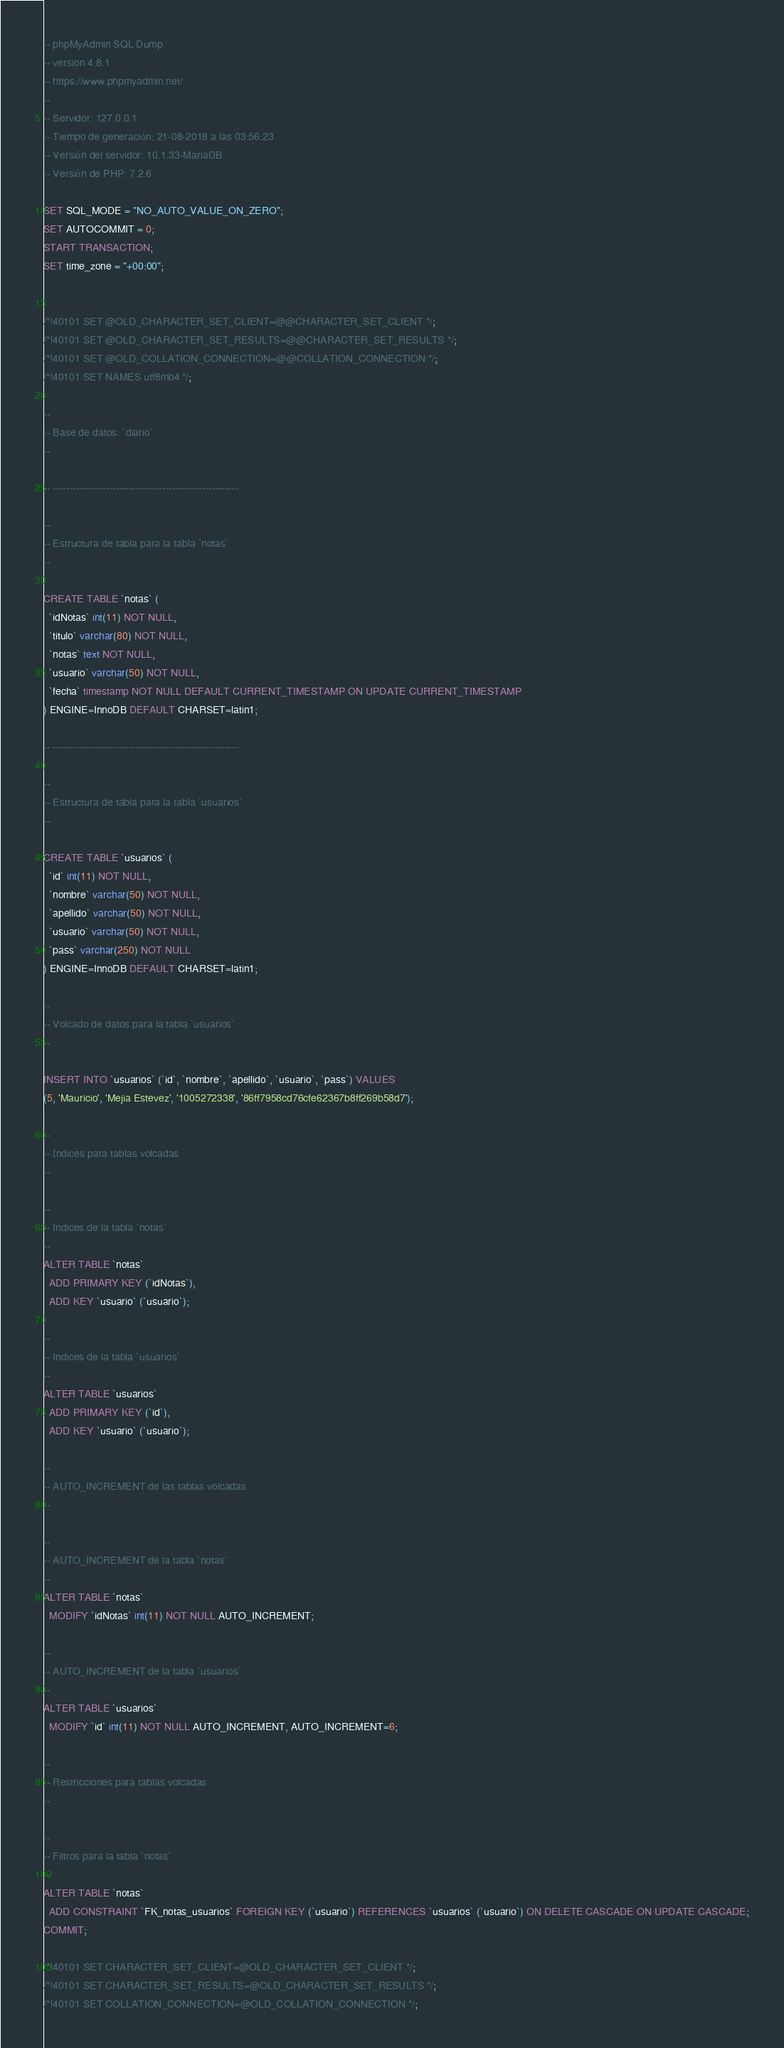<code> <loc_0><loc_0><loc_500><loc_500><_SQL_>-- phpMyAdmin SQL Dump
-- version 4.8.1
-- https://www.phpmyadmin.net/
--
-- Servidor: 127.0.0.1
-- Tiempo de generación: 21-08-2018 a las 03:56:23
-- Versión del servidor: 10.1.33-MariaDB
-- Versión de PHP: 7.2.6

SET SQL_MODE = "NO_AUTO_VALUE_ON_ZERO";
SET AUTOCOMMIT = 0;
START TRANSACTION;
SET time_zone = "+00:00";


/*!40101 SET @OLD_CHARACTER_SET_CLIENT=@@CHARACTER_SET_CLIENT */;
/*!40101 SET @OLD_CHARACTER_SET_RESULTS=@@CHARACTER_SET_RESULTS */;
/*!40101 SET @OLD_COLLATION_CONNECTION=@@COLLATION_CONNECTION */;
/*!40101 SET NAMES utf8mb4 */;

--
-- Base de datos: `diario`
--

-- --------------------------------------------------------

--
-- Estructura de tabla para la tabla `notas`
--

CREATE TABLE `notas` (
  `idNotas` int(11) NOT NULL,
  `titulo` varchar(80) NOT NULL,
  `notas` text NOT NULL,
  `usuario` varchar(50) NOT NULL,
  `fecha` timestamp NOT NULL DEFAULT CURRENT_TIMESTAMP ON UPDATE CURRENT_TIMESTAMP
) ENGINE=InnoDB DEFAULT CHARSET=latin1;

-- --------------------------------------------------------

--
-- Estructura de tabla para la tabla `usuarios`
--

CREATE TABLE `usuarios` (
  `id` int(11) NOT NULL,
  `nombre` varchar(50) NOT NULL,
  `apellido` varchar(50) NOT NULL,
  `usuario` varchar(50) NOT NULL,
  `pass` varchar(250) NOT NULL
) ENGINE=InnoDB DEFAULT CHARSET=latin1;

--
-- Volcado de datos para la tabla `usuarios`
--

INSERT INTO `usuarios` (`id`, `nombre`, `apellido`, `usuario`, `pass`) VALUES
(5, 'Mauricio', 'Mejia Estevez', '1005272338', '86ff7958cd76cfe62367b8ff269b58d7');

--
-- Índices para tablas volcadas
--

--
-- Indices de la tabla `notas`
--
ALTER TABLE `notas`
  ADD PRIMARY KEY (`idNotas`),
  ADD KEY `usuario` (`usuario`);

--
-- Indices de la tabla `usuarios`
--
ALTER TABLE `usuarios`
  ADD PRIMARY KEY (`id`),
  ADD KEY `usuario` (`usuario`);

--
-- AUTO_INCREMENT de las tablas volcadas
--

--
-- AUTO_INCREMENT de la tabla `notas`
--
ALTER TABLE `notas`
  MODIFY `idNotas` int(11) NOT NULL AUTO_INCREMENT;

--
-- AUTO_INCREMENT de la tabla `usuarios`
--
ALTER TABLE `usuarios`
  MODIFY `id` int(11) NOT NULL AUTO_INCREMENT, AUTO_INCREMENT=6;

--
-- Restricciones para tablas volcadas
--

--
-- Filtros para la tabla `notas`
--
ALTER TABLE `notas`
  ADD CONSTRAINT `FK_notas_usuarios` FOREIGN KEY (`usuario`) REFERENCES `usuarios` (`usuario`) ON DELETE CASCADE ON UPDATE CASCADE;
COMMIT;

/*!40101 SET CHARACTER_SET_CLIENT=@OLD_CHARACTER_SET_CLIENT */;
/*!40101 SET CHARACTER_SET_RESULTS=@OLD_CHARACTER_SET_RESULTS */;
/*!40101 SET COLLATION_CONNECTION=@OLD_COLLATION_CONNECTION */;
</code> 